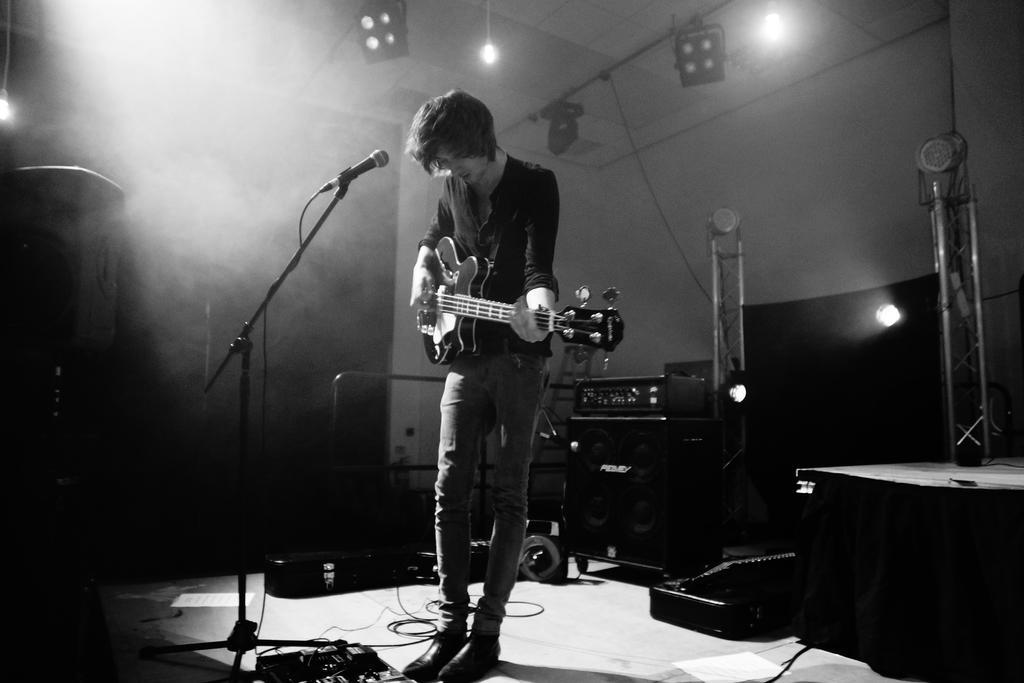Could you give a brief overview of what you see in this image? A black and white picture. This man is playing a guitar in-front of mic. On top there are lights. This is a sound box. 